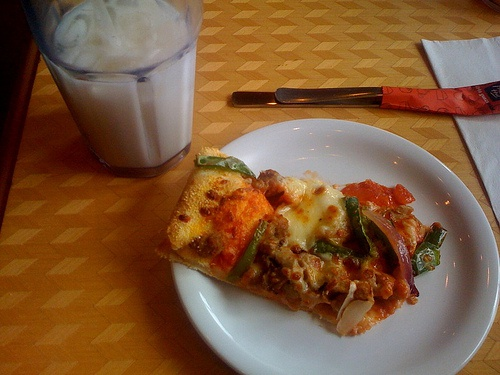Describe the objects in this image and their specific colors. I can see dining table in olive, maroon, darkgray, black, and gray tones, pizza in black, maroon, and brown tones, cup in black, darkgray, gray, and maroon tones, and knife in black, maroon, and brown tones in this image. 